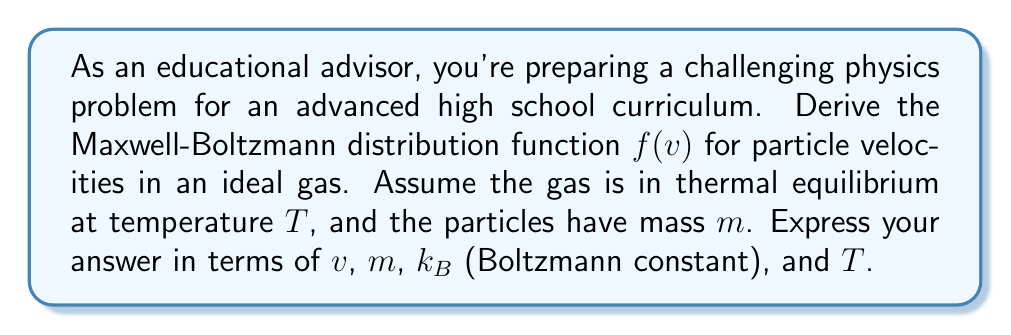What is the answer to this math problem? To derive the Maxwell-Boltzmann distribution, we'll follow these steps:

1) Start with the Boltzmann distribution for energy:
   $$P(E) \propto e^{-E/k_BT}$$

2) For an ideal gas, the energy is purely kinetic:
   $$E = \frac{1}{2}mv^2$$

3) Substitute this into the Boltzmann distribution:
   $$P(v) \propto e^{-mv^2/2k_BT}$$

4) We need to normalize this distribution. In 3D velocity space, the volume element is $4\pi v^2 dv$, so:
   $$f(v) = A \cdot 4\pi v^2 e^{-mv^2/2k_BT}$$

5) To find $A$, we use the normalization condition:
   $$\int_0^\infty f(v) dv = 1$$

6) Solve this integral:
   $$1 = A \cdot 4\pi \int_0^\infty v^2 e^{-mv^2/2k_BT} dv$$

7) This integral can be solved using the substitution $u = mv^2/2k_BT$:
   $$1 = A \cdot 4\pi \left(\frac{2k_BT}{m}\right)^{3/2} \cdot \frac{\sqrt{\pi}}{2}$$

8) Solve for $A$:
   $$A = \left(\frac{m}{2\pi k_BT}\right)^{3/2}$$

9) Substitute this back into the distribution function:
   $$f(v) = 4\pi \left(\frac{m}{2\pi k_BT}\right)^{3/2} v^2 e^{-mv^2/2k_BT}$$

This is the Maxwell-Boltzmann distribution for particle velocities in an ideal gas.
Answer: $$f(v) = 4\pi \left(\frac{m}{2\pi k_BT}\right)^{3/2} v^2 e^{-mv^2/2k_BT}$$ 